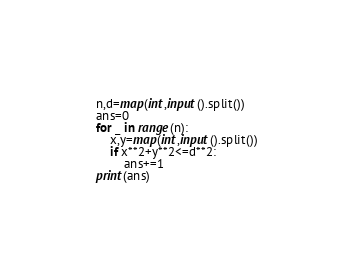<code> <loc_0><loc_0><loc_500><loc_500><_Python_>n,d=map(int,input().split())
ans=0
for _ in range(n):
    x,y=map(int,input().split())
    if x**2+y**2<=d**2:
        ans+=1
print(ans)
</code> 